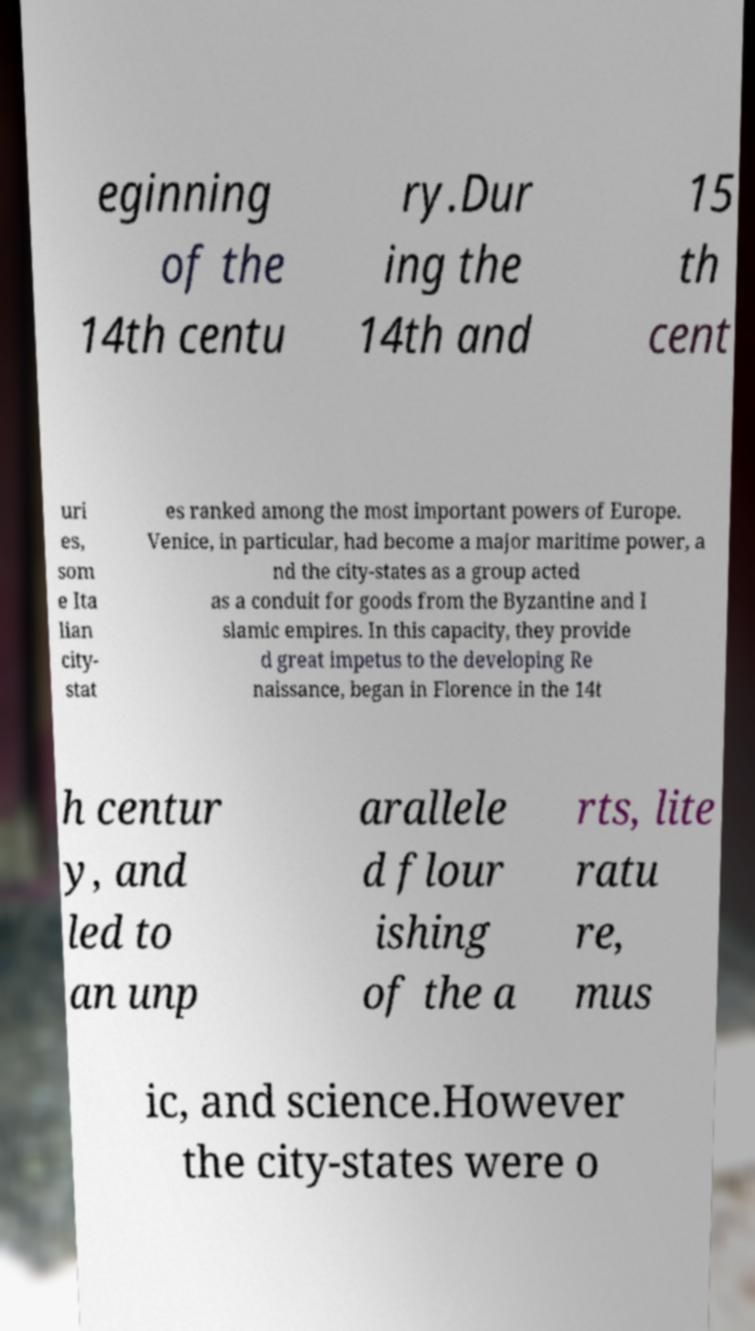Could you assist in decoding the text presented in this image and type it out clearly? eginning of the 14th centu ry.Dur ing the 14th and 15 th cent uri es, som e Ita lian city- stat es ranked among the most important powers of Europe. Venice, in particular, had become a major maritime power, a nd the city-states as a group acted as a conduit for goods from the Byzantine and I slamic empires. In this capacity, they provide d great impetus to the developing Re naissance, began in Florence in the 14t h centur y, and led to an unp arallele d flour ishing of the a rts, lite ratu re, mus ic, and science.However the city-states were o 